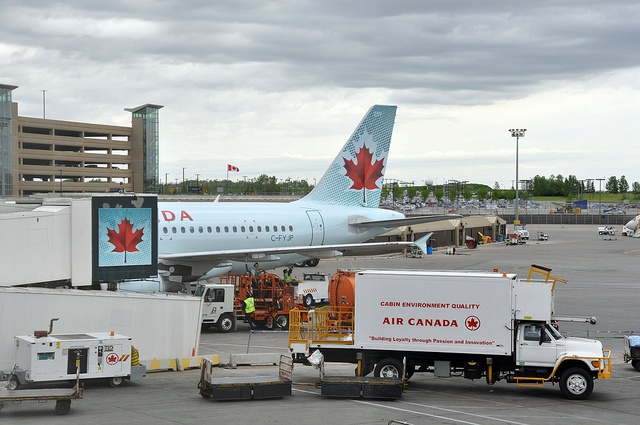Describe the objects in this image and their specific colors. I can see truck in darkgray, black, lightgray, and brown tones, airplane in darkgray, lightblue, and gray tones, truck in darkgray, black, maroon, and gray tones, truck in darkgray, black, gray, and lightgray tones, and car in darkgray, black, gray, and lightblue tones in this image. 